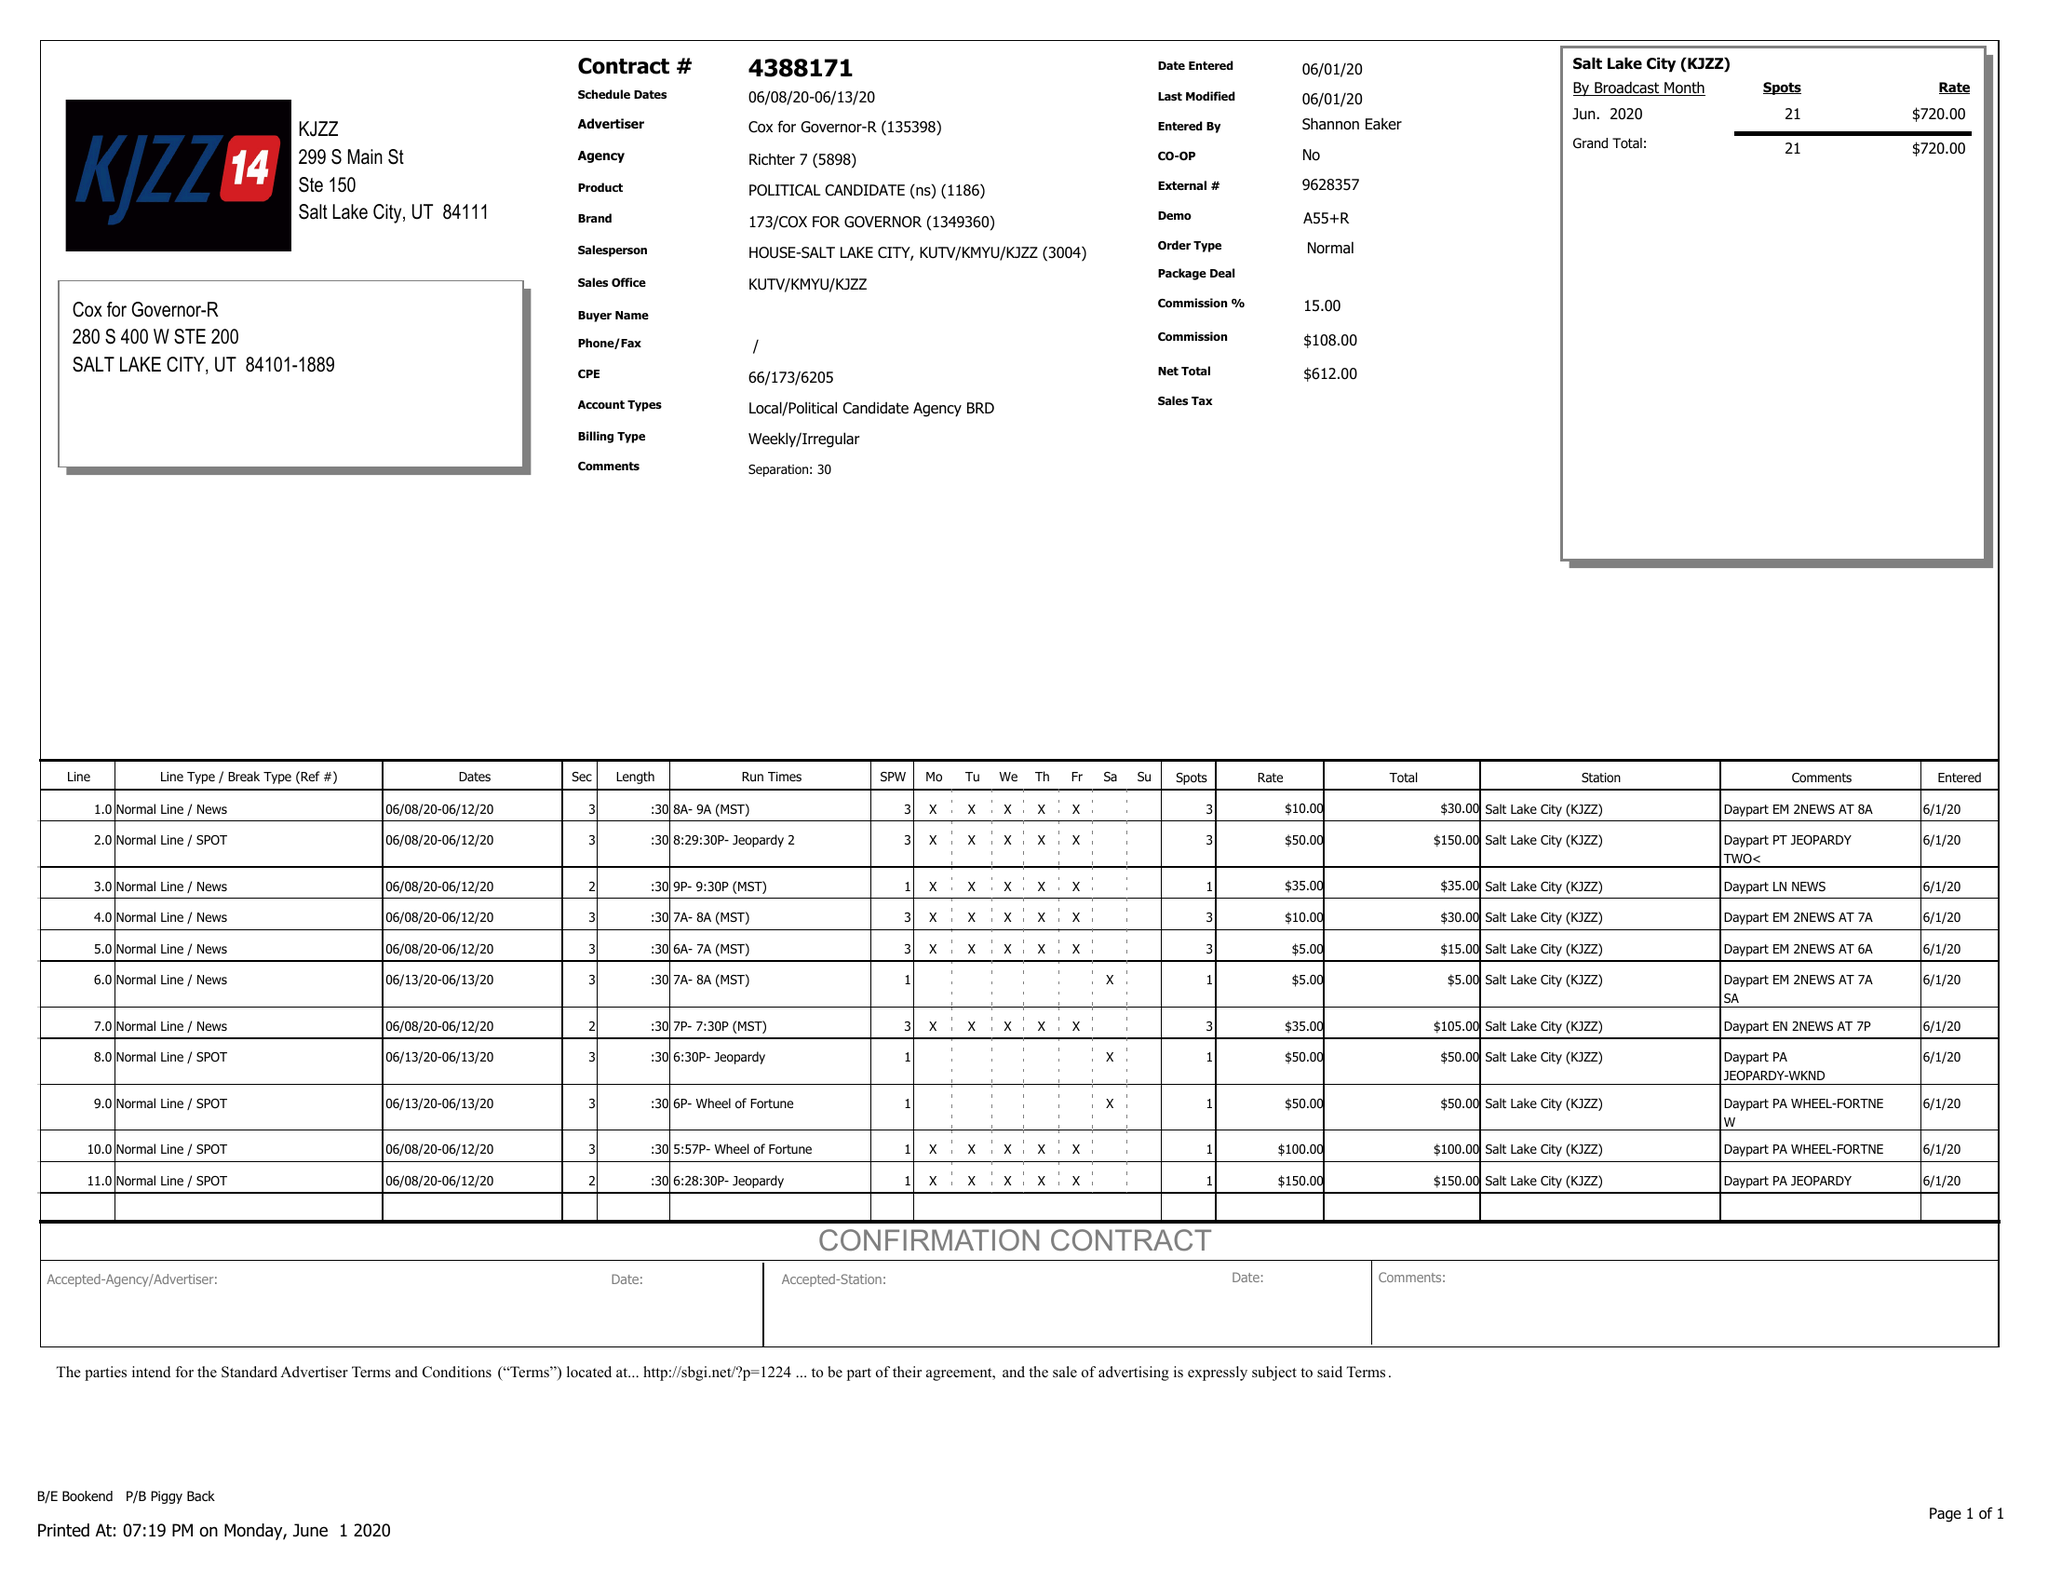What is the value for the flight_to?
Answer the question using a single word or phrase. 06/13/20 